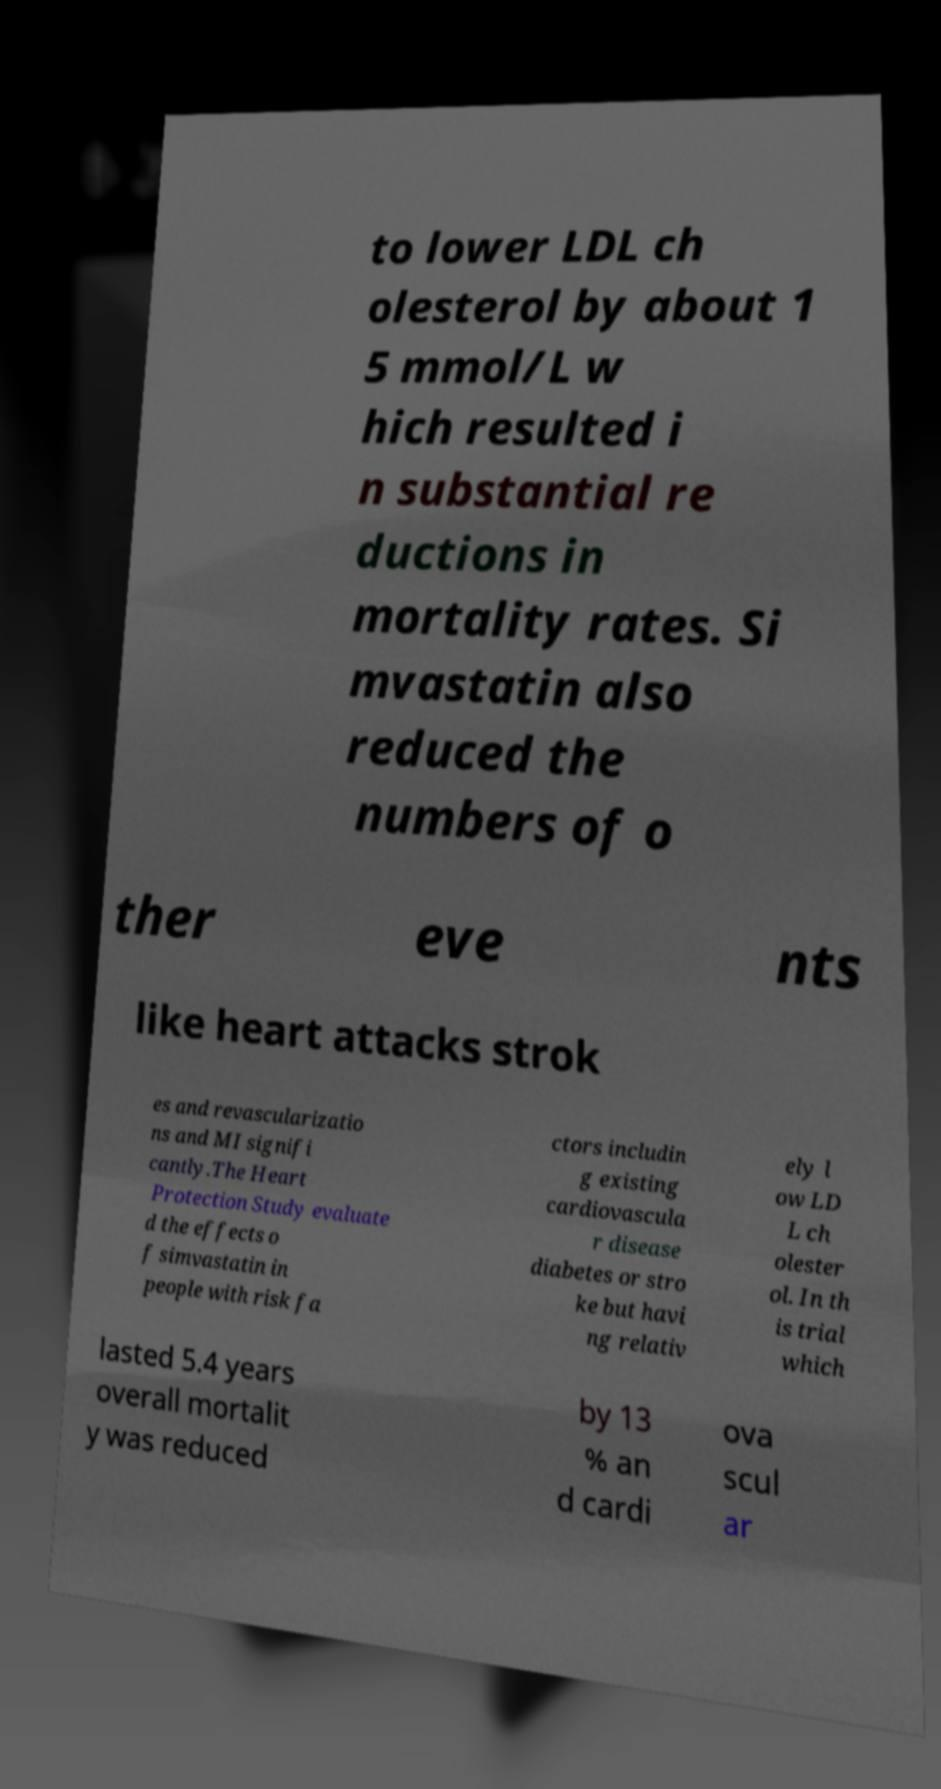I need the written content from this picture converted into text. Can you do that? to lower LDL ch olesterol by about 1 5 mmol/L w hich resulted i n substantial re ductions in mortality rates. Si mvastatin also reduced the numbers of o ther eve nts like heart attacks strok es and revascularizatio ns and MI signifi cantly.The Heart Protection Study evaluate d the effects o f simvastatin in people with risk fa ctors includin g existing cardiovascula r disease diabetes or stro ke but havi ng relativ ely l ow LD L ch olester ol. In th is trial which lasted 5.4 years overall mortalit y was reduced by 13 % an d cardi ova scul ar 